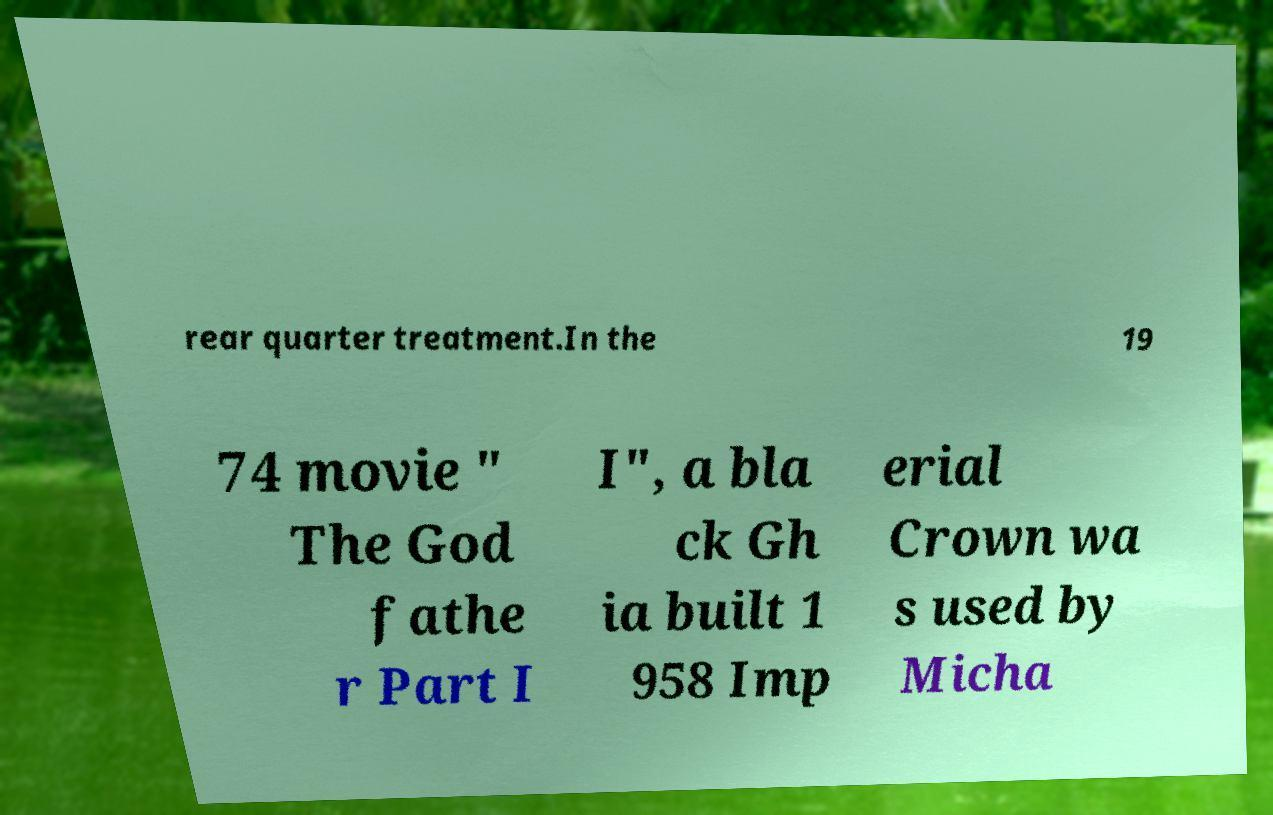Please read and relay the text visible in this image. What does it say? rear quarter treatment.In the 19 74 movie " The God fathe r Part I I", a bla ck Gh ia built 1 958 Imp erial Crown wa s used by Micha 